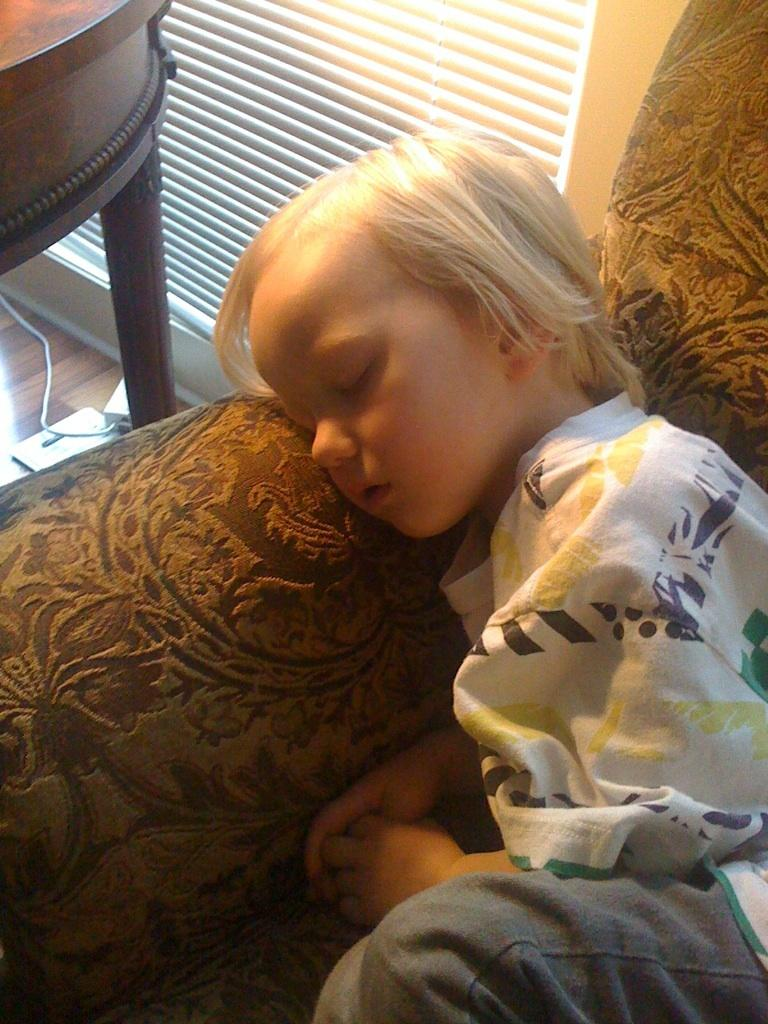What is present in the image that can be used to control light? There is a window blind in the image that can be used to control light. What type of furniture is visible in the image? There is a table in the image. Who is present in the image? There is a boy in the image. What is the boy wearing? The boy is wearing a white dress. Where is the boy in the image? The boy is sleeping on a sofa. What impulse does the boy have to cry in the image? There is no indication in the image that the boy has any impulse to cry. Does the boy have a pocket in the white dress he is wearing? The provided facts do not mention any pockets on the boy's white dress. 